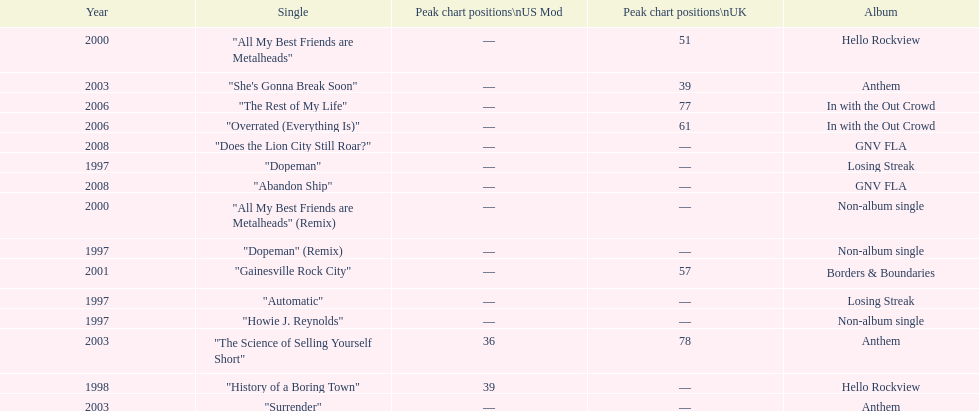What was the average chart position of their singles in the uk? 60.5. 